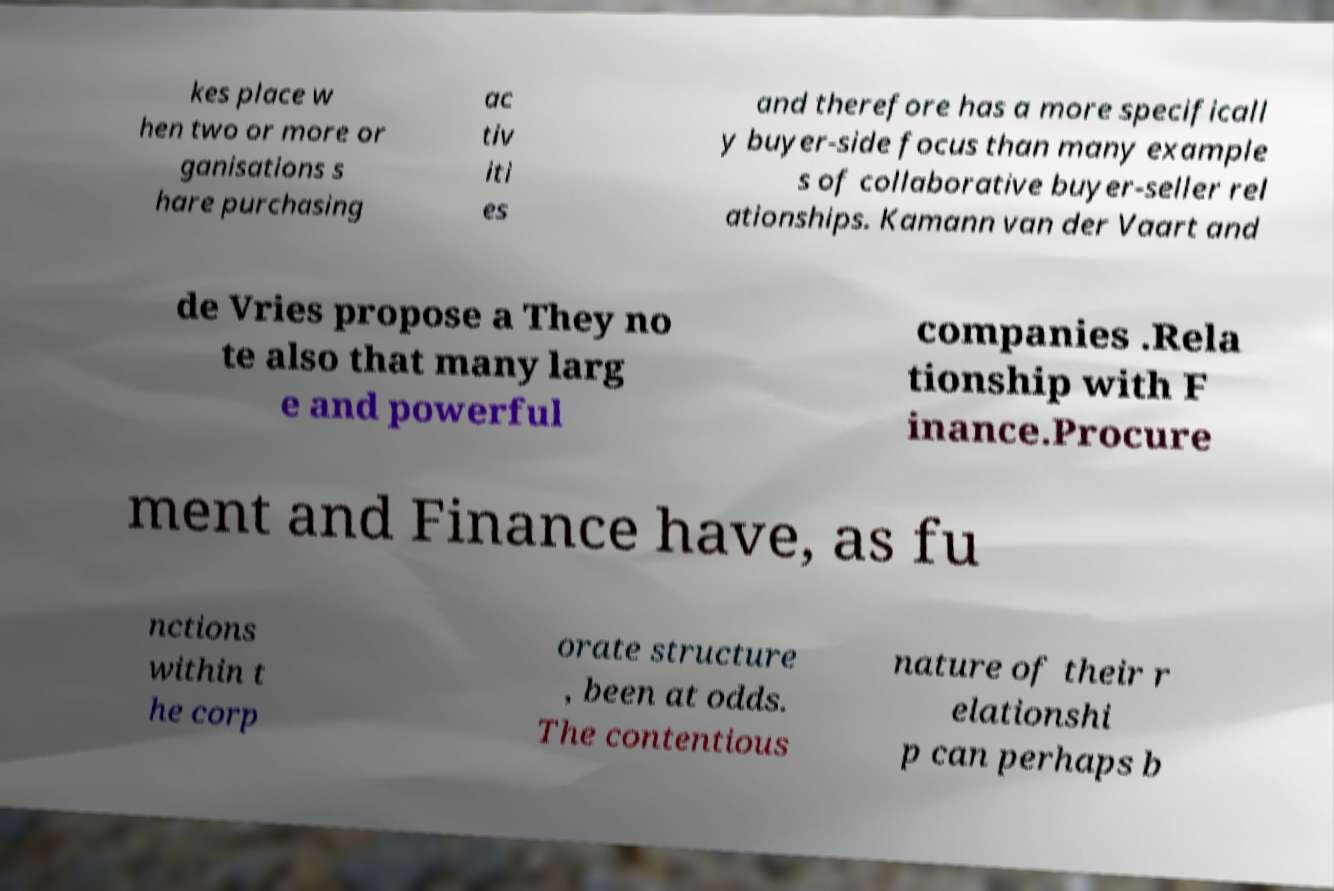Could you extract and type out the text from this image? kes place w hen two or more or ganisations s hare purchasing ac tiv iti es and therefore has a more specificall y buyer-side focus than many example s of collaborative buyer-seller rel ationships. Kamann van der Vaart and de Vries propose a They no te also that many larg e and powerful companies .Rela tionship with F inance.Procure ment and Finance have, as fu nctions within t he corp orate structure , been at odds. The contentious nature of their r elationshi p can perhaps b 